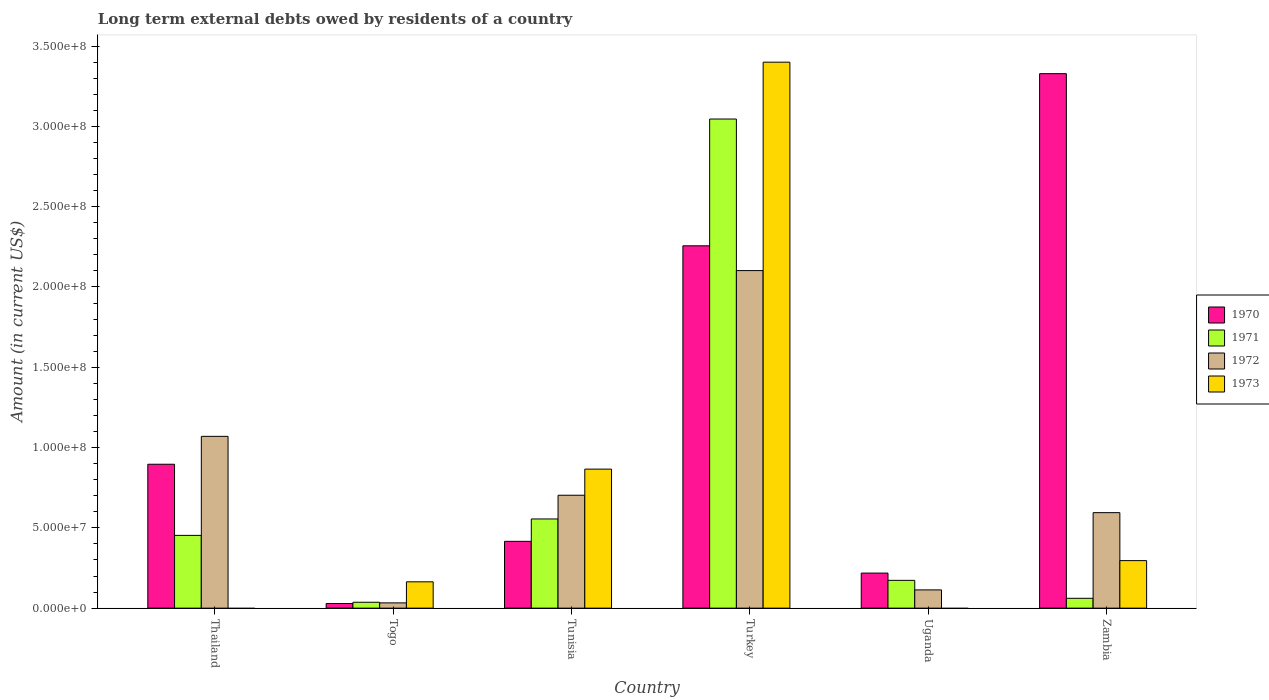How many different coloured bars are there?
Give a very brief answer. 4. How many groups of bars are there?
Offer a very short reply. 6. How many bars are there on the 5th tick from the left?
Give a very brief answer. 3. How many bars are there on the 4th tick from the right?
Your response must be concise. 4. What is the label of the 3rd group of bars from the left?
Provide a short and direct response. Tunisia. In how many cases, is the number of bars for a given country not equal to the number of legend labels?
Give a very brief answer. 2. What is the amount of long-term external debts owed by residents in 1972 in Zambia?
Your response must be concise. 5.95e+07. Across all countries, what is the maximum amount of long-term external debts owed by residents in 1970?
Your response must be concise. 3.33e+08. Across all countries, what is the minimum amount of long-term external debts owed by residents in 1972?
Keep it short and to the point. 3.28e+06. In which country was the amount of long-term external debts owed by residents in 1971 maximum?
Keep it short and to the point. Turkey. What is the total amount of long-term external debts owed by residents in 1973 in the graph?
Offer a very short reply. 4.73e+08. What is the difference between the amount of long-term external debts owed by residents in 1972 in Togo and that in Turkey?
Provide a succinct answer. -2.07e+08. What is the difference between the amount of long-term external debts owed by residents in 1972 in Tunisia and the amount of long-term external debts owed by residents in 1970 in Zambia?
Ensure brevity in your answer.  -2.62e+08. What is the average amount of long-term external debts owed by residents in 1973 per country?
Make the answer very short. 7.88e+07. What is the difference between the amount of long-term external debts owed by residents of/in 1970 and amount of long-term external debts owed by residents of/in 1973 in Zambia?
Your answer should be very brief. 3.03e+08. What is the ratio of the amount of long-term external debts owed by residents in 1972 in Togo to that in Tunisia?
Offer a very short reply. 0.05. Is the difference between the amount of long-term external debts owed by residents in 1970 in Tunisia and Zambia greater than the difference between the amount of long-term external debts owed by residents in 1973 in Tunisia and Zambia?
Make the answer very short. No. What is the difference between the highest and the second highest amount of long-term external debts owed by residents in 1970?
Ensure brevity in your answer.  2.43e+08. What is the difference between the highest and the lowest amount of long-term external debts owed by residents in 1970?
Offer a terse response. 3.30e+08. Is it the case that in every country, the sum of the amount of long-term external debts owed by residents in 1971 and amount of long-term external debts owed by residents in 1970 is greater than the sum of amount of long-term external debts owed by residents in 1973 and amount of long-term external debts owed by residents in 1972?
Your answer should be very brief. No. How many bars are there?
Your answer should be very brief. 22. What is the difference between two consecutive major ticks on the Y-axis?
Provide a short and direct response. 5.00e+07. Where does the legend appear in the graph?
Provide a succinct answer. Center right. How many legend labels are there?
Ensure brevity in your answer.  4. How are the legend labels stacked?
Offer a terse response. Vertical. What is the title of the graph?
Offer a terse response. Long term external debts owed by residents of a country. What is the Amount (in current US$) of 1970 in Thailand?
Your answer should be compact. 8.96e+07. What is the Amount (in current US$) in 1971 in Thailand?
Make the answer very short. 4.53e+07. What is the Amount (in current US$) of 1972 in Thailand?
Offer a terse response. 1.07e+08. What is the Amount (in current US$) of 1973 in Thailand?
Your answer should be very brief. 0. What is the Amount (in current US$) of 1970 in Togo?
Your response must be concise. 2.89e+06. What is the Amount (in current US$) in 1971 in Togo?
Make the answer very short. 3.67e+06. What is the Amount (in current US$) of 1972 in Togo?
Your response must be concise. 3.28e+06. What is the Amount (in current US$) in 1973 in Togo?
Your response must be concise. 1.64e+07. What is the Amount (in current US$) of 1970 in Tunisia?
Your answer should be very brief. 4.16e+07. What is the Amount (in current US$) in 1971 in Tunisia?
Offer a terse response. 5.55e+07. What is the Amount (in current US$) of 1972 in Tunisia?
Your answer should be very brief. 7.03e+07. What is the Amount (in current US$) of 1973 in Tunisia?
Provide a short and direct response. 8.66e+07. What is the Amount (in current US$) in 1970 in Turkey?
Your answer should be very brief. 2.26e+08. What is the Amount (in current US$) of 1971 in Turkey?
Make the answer very short. 3.05e+08. What is the Amount (in current US$) in 1972 in Turkey?
Ensure brevity in your answer.  2.10e+08. What is the Amount (in current US$) in 1973 in Turkey?
Your response must be concise. 3.40e+08. What is the Amount (in current US$) of 1970 in Uganda?
Keep it short and to the point. 2.18e+07. What is the Amount (in current US$) in 1971 in Uganda?
Offer a very short reply. 1.73e+07. What is the Amount (in current US$) in 1972 in Uganda?
Provide a succinct answer. 1.14e+07. What is the Amount (in current US$) of 1970 in Zambia?
Your response must be concise. 3.33e+08. What is the Amount (in current US$) in 1971 in Zambia?
Give a very brief answer. 6.13e+06. What is the Amount (in current US$) in 1972 in Zambia?
Make the answer very short. 5.95e+07. What is the Amount (in current US$) of 1973 in Zambia?
Give a very brief answer. 2.96e+07. Across all countries, what is the maximum Amount (in current US$) in 1970?
Ensure brevity in your answer.  3.33e+08. Across all countries, what is the maximum Amount (in current US$) in 1971?
Ensure brevity in your answer.  3.05e+08. Across all countries, what is the maximum Amount (in current US$) in 1972?
Keep it short and to the point. 2.10e+08. Across all countries, what is the maximum Amount (in current US$) in 1973?
Offer a terse response. 3.40e+08. Across all countries, what is the minimum Amount (in current US$) of 1970?
Provide a succinct answer. 2.89e+06. Across all countries, what is the minimum Amount (in current US$) in 1971?
Make the answer very short. 3.67e+06. Across all countries, what is the minimum Amount (in current US$) of 1972?
Your answer should be compact. 3.28e+06. Across all countries, what is the minimum Amount (in current US$) in 1973?
Keep it short and to the point. 0. What is the total Amount (in current US$) of 1970 in the graph?
Make the answer very short. 7.14e+08. What is the total Amount (in current US$) of 1971 in the graph?
Offer a very short reply. 4.33e+08. What is the total Amount (in current US$) in 1972 in the graph?
Make the answer very short. 4.62e+08. What is the total Amount (in current US$) of 1973 in the graph?
Keep it short and to the point. 4.73e+08. What is the difference between the Amount (in current US$) of 1970 in Thailand and that in Togo?
Offer a terse response. 8.67e+07. What is the difference between the Amount (in current US$) of 1971 in Thailand and that in Togo?
Offer a very short reply. 4.16e+07. What is the difference between the Amount (in current US$) in 1972 in Thailand and that in Togo?
Make the answer very short. 1.04e+08. What is the difference between the Amount (in current US$) in 1970 in Thailand and that in Tunisia?
Keep it short and to the point. 4.80e+07. What is the difference between the Amount (in current US$) of 1971 in Thailand and that in Tunisia?
Keep it short and to the point. -1.02e+07. What is the difference between the Amount (in current US$) of 1972 in Thailand and that in Tunisia?
Your answer should be very brief. 3.67e+07. What is the difference between the Amount (in current US$) in 1970 in Thailand and that in Turkey?
Your answer should be very brief. -1.36e+08. What is the difference between the Amount (in current US$) in 1971 in Thailand and that in Turkey?
Provide a succinct answer. -2.59e+08. What is the difference between the Amount (in current US$) of 1972 in Thailand and that in Turkey?
Provide a short and direct response. -1.03e+08. What is the difference between the Amount (in current US$) of 1970 in Thailand and that in Uganda?
Offer a terse response. 6.78e+07. What is the difference between the Amount (in current US$) of 1971 in Thailand and that in Uganda?
Your response must be concise. 2.80e+07. What is the difference between the Amount (in current US$) in 1972 in Thailand and that in Uganda?
Offer a very short reply. 9.56e+07. What is the difference between the Amount (in current US$) in 1970 in Thailand and that in Zambia?
Your response must be concise. -2.43e+08. What is the difference between the Amount (in current US$) in 1971 in Thailand and that in Zambia?
Make the answer very short. 3.92e+07. What is the difference between the Amount (in current US$) of 1972 in Thailand and that in Zambia?
Provide a short and direct response. 4.75e+07. What is the difference between the Amount (in current US$) of 1970 in Togo and that in Tunisia?
Make the answer very short. -3.87e+07. What is the difference between the Amount (in current US$) of 1971 in Togo and that in Tunisia?
Provide a short and direct response. -5.19e+07. What is the difference between the Amount (in current US$) in 1972 in Togo and that in Tunisia?
Keep it short and to the point. -6.70e+07. What is the difference between the Amount (in current US$) in 1973 in Togo and that in Tunisia?
Make the answer very short. -7.02e+07. What is the difference between the Amount (in current US$) in 1970 in Togo and that in Turkey?
Your answer should be compact. -2.23e+08. What is the difference between the Amount (in current US$) of 1971 in Togo and that in Turkey?
Make the answer very short. -3.01e+08. What is the difference between the Amount (in current US$) of 1972 in Togo and that in Turkey?
Make the answer very short. -2.07e+08. What is the difference between the Amount (in current US$) of 1973 in Togo and that in Turkey?
Make the answer very short. -3.24e+08. What is the difference between the Amount (in current US$) of 1970 in Togo and that in Uganda?
Offer a very short reply. -1.89e+07. What is the difference between the Amount (in current US$) of 1971 in Togo and that in Uganda?
Offer a terse response. -1.36e+07. What is the difference between the Amount (in current US$) of 1972 in Togo and that in Uganda?
Provide a succinct answer. -8.09e+06. What is the difference between the Amount (in current US$) of 1970 in Togo and that in Zambia?
Make the answer very short. -3.30e+08. What is the difference between the Amount (in current US$) of 1971 in Togo and that in Zambia?
Offer a terse response. -2.46e+06. What is the difference between the Amount (in current US$) of 1972 in Togo and that in Zambia?
Provide a short and direct response. -5.62e+07. What is the difference between the Amount (in current US$) in 1973 in Togo and that in Zambia?
Your answer should be compact. -1.32e+07. What is the difference between the Amount (in current US$) in 1970 in Tunisia and that in Turkey?
Provide a short and direct response. -1.84e+08. What is the difference between the Amount (in current US$) in 1971 in Tunisia and that in Turkey?
Ensure brevity in your answer.  -2.49e+08. What is the difference between the Amount (in current US$) of 1972 in Tunisia and that in Turkey?
Ensure brevity in your answer.  -1.40e+08. What is the difference between the Amount (in current US$) in 1973 in Tunisia and that in Turkey?
Provide a succinct answer. -2.53e+08. What is the difference between the Amount (in current US$) of 1970 in Tunisia and that in Uganda?
Give a very brief answer. 1.98e+07. What is the difference between the Amount (in current US$) of 1971 in Tunisia and that in Uganda?
Ensure brevity in your answer.  3.82e+07. What is the difference between the Amount (in current US$) in 1972 in Tunisia and that in Uganda?
Your response must be concise. 5.89e+07. What is the difference between the Amount (in current US$) of 1970 in Tunisia and that in Zambia?
Your response must be concise. -2.91e+08. What is the difference between the Amount (in current US$) in 1971 in Tunisia and that in Zambia?
Offer a terse response. 4.94e+07. What is the difference between the Amount (in current US$) of 1972 in Tunisia and that in Zambia?
Ensure brevity in your answer.  1.08e+07. What is the difference between the Amount (in current US$) in 1973 in Tunisia and that in Zambia?
Make the answer very short. 5.70e+07. What is the difference between the Amount (in current US$) of 1970 in Turkey and that in Uganda?
Ensure brevity in your answer.  2.04e+08. What is the difference between the Amount (in current US$) of 1971 in Turkey and that in Uganda?
Keep it short and to the point. 2.87e+08. What is the difference between the Amount (in current US$) in 1972 in Turkey and that in Uganda?
Give a very brief answer. 1.99e+08. What is the difference between the Amount (in current US$) in 1970 in Turkey and that in Zambia?
Ensure brevity in your answer.  -1.07e+08. What is the difference between the Amount (in current US$) in 1971 in Turkey and that in Zambia?
Offer a terse response. 2.98e+08. What is the difference between the Amount (in current US$) of 1972 in Turkey and that in Zambia?
Give a very brief answer. 1.51e+08. What is the difference between the Amount (in current US$) of 1973 in Turkey and that in Zambia?
Offer a terse response. 3.10e+08. What is the difference between the Amount (in current US$) in 1970 in Uganda and that in Zambia?
Provide a succinct answer. -3.11e+08. What is the difference between the Amount (in current US$) of 1971 in Uganda and that in Zambia?
Offer a very short reply. 1.12e+07. What is the difference between the Amount (in current US$) in 1972 in Uganda and that in Zambia?
Offer a terse response. -4.81e+07. What is the difference between the Amount (in current US$) in 1970 in Thailand and the Amount (in current US$) in 1971 in Togo?
Offer a very short reply. 8.59e+07. What is the difference between the Amount (in current US$) of 1970 in Thailand and the Amount (in current US$) of 1972 in Togo?
Make the answer very short. 8.63e+07. What is the difference between the Amount (in current US$) in 1970 in Thailand and the Amount (in current US$) in 1973 in Togo?
Make the answer very short. 7.32e+07. What is the difference between the Amount (in current US$) of 1971 in Thailand and the Amount (in current US$) of 1972 in Togo?
Give a very brief answer. 4.20e+07. What is the difference between the Amount (in current US$) in 1971 in Thailand and the Amount (in current US$) in 1973 in Togo?
Your response must be concise. 2.89e+07. What is the difference between the Amount (in current US$) in 1972 in Thailand and the Amount (in current US$) in 1973 in Togo?
Ensure brevity in your answer.  9.06e+07. What is the difference between the Amount (in current US$) of 1970 in Thailand and the Amount (in current US$) of 1971 in Tunisia?
Provide a succinct answer. 3.41e+07. What is the difference between the Amount (in current US$) of 1970 in Thailand and the Amount (in current US$) of 1972 in Tunisia?
Ensure brevity in your answer.  1.93e+07. What is the difference between the Amount (in current US$) of 1970 in Thailand and the Amount (in current US$) of 1973 in Tunisia?
Give a very brief answer. 3.04e+06. What is the difference between the Amount (in current US$) of 1971 in Thailand and the Amount (in current US$) of 1972 in Tunisia?
Offer a terse response. -2.50e+07. What is the difference between the Amount (in current US$) in 1971 in Thailand and the Amount (in current US$) in 1973 in Tunisia?
Offer a terse response. -4.13e+07. What is the difference between the Amount (in current US$) of 1972 in Thailand and the Amount (in current US$) of 1973 in Tunisia?
Offer a very short reply. 2.04e+07. What is the difference between the Amount (in current US$) in 1970 in Thailand and the Amount (in current US$) in 1971 in Turkey?
Offer a very short reply. -2.15e+08. What is the difference between the Amount (in current US$) in 1970 in Thailand and the Amount (in current US$) in 1972 in Turkey?
Your answer should be very brief. -1.21e+08. What is the difference between the Amount (in current US$) in 1970 in Thailand and the Amount (in current US$) in 1973 in Turkey?
Your response must be concise. -2.50e+08. What is the difference between the Amount (in current US$) of 1971 in Thailand and the Amount (in current US$) of 1972 in Turkey?
Offer a terse response. -1.65e+08. What is the difference between the Amount (in current US$) of 1971 in Thailand and the Amount (in current US$) of 1973 in Turkey?
Make the answer very short. -2.95e+08. What is the difference between the Amount (in current US$) of 1972 in Thailand and the Amount (in current US$) of 1973 in Turkey?
Make the answer very short. -2.33e+08. What is the difference between the Amount (in current US$) of 1970 in Thailand and the Amount (in current US$) of 1971 in Uganda?
Your answer should be compact. 7.23e+07. What is the difference between the Amount (in current US$) of 1970 in Thailand and the Amount (in current US$) of 1972 in Uganda?
Your answer should be compact. 7.82e+07. What is the difference between the Amount (in current US$) in 1971 in Thailand and the Amount (in current US$) in 1972 in Uganda?
Keep it short and to the point. 3.39e+07. What is the difference between the Amount (in current US$) in 1970 in Thailand and the Amount (in current US$) in 1971 in Zambia?
Your answer should be very brief. 8.35e+07. What is the difference between the Amount (in current US$) in 1970 in Thailand and the Amount (in current US$) in 1972 in Zambia?
Ensure brevity in your answer.  3.01e+07. What is the difference between the Amount (in current US$) of 1970 in Thailand and the Amount (in current US$) of 1973 in Zambia?
Your response must be concise. 6.00e+07. What is the difference between the Amount (in current US$) of 1971 in Thailand and the Amount (in current US$) of 1972 in Zambia?
Make the answer very short. -1.42e+07. What is the difference between the Amount (in current US$) of 1971 in Thailand and the Amount (in current US$) of 1973 in Zambia?
Provide a short and direct response. 1.57e+07. What is the difference between the Amount (in current US$) of 1972 in Thailand and the Amount (in current US$) of 1973 in Zambia?
Ensure brevity in your answer.  7.74e+07. What is the difference between the Amount (in current US$) in 1970 in Togo and the Amount (in current US$) in 1971 in Tunisia?
Offer a very short reply. -5.26e+07. What is the difference between the Amount (in current US$) of 1970 in Togo and the Amount (in current US$) of 1972 in Tunisia?
Give a very brief answer. -6.74e+07. What is the difference between the Amount (in current US$) of 1970 in Togo and the Amount (in current US$) of 1973 in Tunisia?
Your response must be concise. -8.37e+07. What is the difference between the Amount (in current US$) of 1971 in Togo and the Amount (in current US$) of 1972 in Tunisia?
Your answer should be compact. -6.66e+07. What is the difference between the Amount (in current US$) of 1971 in Togo and the Amount (in current US$) of 1973 in Tunisia?
Your answer should be compact. -8.29e+07. What is the difference between the Amount (in current US$) of 1972 in Togo and the Amount (in current US$) of 1973 in Tunisia?
Offer a terse response. -8.33e+07. What is the difference between the Amount (in current US$) of 1970 in Togo and the Amount (in current US$) of 1971 in Turkey?
Provide a short and direct response. -3.02e+08. What is the difference between the Amount (in current US$) of 1970 in Togo and the Amount (in current US$) of 1972 in Turkey?
Ensure brevity in your answer.  -2.07e+08. What is the difference between the Amount (in current US$) in 1970 in Togo and the Amount (in current US$) in 1973 in Turkey?
Keep it short and to the point. -3.37e+08. What is the difference between the Amount (in current US$) of 1971 in Togo and the Amount (in current US$) of 1972 in Turkey?
Offer a terse response. -2.07e+08. What is the difference between the Amount (in current US$) in 1971 in Togo and the Amount (in current US$) in 1973 in Turkey?
Your answer should be very brief. -3.36e+08. What is the difference between the Amount (in current US$) of 1972 in Togo and the Amount (in current US$) of 1973 in Turkey?
Your answer should be very brief. -3.37e+08. What is the difference between the Amount (in current US$) in 1970 in Togo and the Amount (in current US$) in 1971 in Uganda?
Give a very brief answer. -1.44e+07. What is the difference between the Amount (in current US$) in 1970 in Togo and the Amount (in current US$) in 1972 in Uganda?
Your answer should be very brief. -8.47e+06. What is the difference between the Amount (in current US$) in 1971 in Togo and the Amount (in current US$) in 1972 in Uganda?
Make the answer very short. -7.70e+06. What is the difference between the Amount (in current US$) of 1970 in Togo and the Amount (in current US$) of 1971 in Zambia?
Offer a very short reply. -3.24e+06. What is the difference between the Amount (in current US$) of 1970 in Togo and the Amount (in current US$) of 1972 in Zambia?
Make the answer very short. -5.66e+07. What is the difference between the Amount (in current US$) in 1970 in Togo and the Amount (in current US$) in 1973 in Zambia?
Offer a very short reply. -2.67e+07. What is the difference between the Amount (in current US$) in 1971 in Togo and the Amount (in current US$) in 1972 in Zambia?
Keep it short and to the point. -5.58e+07. What is the difference between the Amount (in current US$) in 1971 in Togo and the Amount (in current US$) in 1973 in Zambia?
Keep it short and to the point. -2.59e+07. What is the difference between the Amount (in current US$) of 1972 in Togo and the Amount (in current US$) of 1973 in Zambia?
Provide a succinct answer. -2.63e+07. What is the difference between the Amount (in current US$) in 1970 in Tunisia and the Amount (in current US$) in 1971 in Turkey?
Provide a succinct answer. -2.63e+08. What is the difference between the Amount (in current US$) in 1970 in Tunisia and the Amount (in current US$) in 1972 in Turkey?
Make the answer very short. -1.69e+08. What is the difference between the Amount (in current US$) of 1970 in Tunisia and the Amount (in current US$) of 1973 in Turkey?
Offer a very short reply. -2.98e+08. What is the difference between the Amount (in current US$) of 1971 in Tunisia and the Amount (in current US$) of 1972 in Turkey?
Give a very brief answer. -1.55e+08. What is the difference between the Amount (in current US$) in 1971 in Tunisia and the Amount (in current US$) in 1973 in Turkey?
Offer a terse response. -2.84e+08. What is the difference between the Amount (in current US$) of 1972 in Tunisia and the Amount (in current US$) of 1973 in Turkey?
Offer a terse response. -2.70e+08. What is the difference between the Amount (in current US$) in 1970 in Tunisia and the Amount (in current US$) in 1971 in Uganda?
Offer a very short reply. 2.43e+07. What is the difference between the Amount (in current US$) of 1970 in Tunisia and the Amount (in current US$) of 1972 in Uganda?
Your response must be concise. 3.02e+07. What is the difference between the Amount (in current US$) of 1971 in Tunisia and the Amount (in current US$) of 1972 in Uganda?
Keep it short and to the point. 4.42e+07. What is the difference between the Amount (in current US$) of 1970 in Tunisia and the Amount (in current US$) of 1971 in Zambia?
Provide a short and direct response. 3.55e+07. What is the difference between the Amount (in current US$) in 1970 in Tunisia and the Amount (in current US$) in 1972 in Zambia?
Provide a succinct answer. -1.79e+07. What is the difference between the Amount (in current US$) in 1970 in Tunisia and the Amount (in current US$) in 1973 in Zambia?
Ensure brevity in your answer.  1.20e+07. What is the difference between the Amount (in current US$) of 1971 in Tunisia and the Amount (in current US$) of 1972 in Zambia?
Provide a succinct answer. -3.93e+06. What is the difference between the Amount (in current US$) in 1971 in Tunisia and the Amount (in current US$) in 1973 in Zambia?
Your response must be concise. 2.59e+07. What is the difference between the Amount (in current US$) of 1972 in Tunisia and the Amount (in current US$) of 1973 in Zambia?
Offer a terse response. 4.07e+07. What is the difference between the Amount (in current US$) of 1970 in Turkey and the Amount (in current US$) of 1971 in Uganda?
Offer a very short reply. 2.08e+08. What is the difference between the Amount (in current US$) of 1970 in Turkey and the Amount (in current US$) of 1972 in Uganda?
Your answer should be very brief. 2.14e+08. What is the difference between the Amount (in current US$) in 1971 in Turkey and the Amount (in current US$) in 1972 in Uganda?
Make the answer very short. 2.93e+08. What is the difference between the Amount (in current US$) of 1970 in Turkey and the Amount (in current US$) of 1971 in Zambia?
Your response must be concise. 2.19e+08. What is the difference between the Amount (in current US$) of 1970 in Turkey and the Amount (in current US$) of 1972 in Zambia?
Give a very brief answer. 1.66e+08. What is the difference between the Amount (in current US$) of 1970 in Turkey and the Amount (in current US$) of 1973 in Zambia?
Your response must be concise. 1.96e+08. What is the difference between the Amount (in current US$) of 1971 in Turkey and the Amount (in current US$) of 1972 in Zambia?
Offer a very short reply. 2.45e+08. What is the difference between the Amount (in current US$) of 1971 in Turkey and the Amount (in current US$) of 1973 in Zambia?
Make the answer very short. 2.75e+08. What is the difference between the Amount (in current US$) in 1972 in Turkey and the Amount (in current US$) in 1973 in Zambia?
Give a very brief answer. 1.81e+08. What is the difference between the Amount (in current US$) of 1970 in Uganda and the Amount (in current US$) of 1971 in Zambia?
Your response must be concise. 1.57e+07. What is the difference between the Amount (in current US$) in 1970 in Uganda and the Amount (in current US$) in 1972 in Zambia?
Your answer should be compact. -3.76e+07. What is the difference between the Amount (in current US$) of 1970 in Uganda and the Amount (in current US$) of 1973 in Zambia?
Your response must be concise. -7.76e+06. What is the difference between the Amount (in current US$) in 1971 in Uganda and the Amount (in current US$) in 1972 in Zambia?
Provide a succinct answer. -4.22e+07. What is the difference between the Amount (in current US$) in 1971 in Uganda and the Amount (in current US$) in 1973 in Zambia?
Make the answer very short. -1.23e+07. What is the difference between the Amount (in current US$) in 1972 in Uganda and the Amount (in current US$) in 1973 in Zambia?
Offer a very short reply. -1.82e+07. What is the average Amount (in current US$) in 1970 per country?
Provide a short and direct response. 1.19e+08. What is the average Amount (in current US$) of 1971 per country?
Ensure brevity in your answer.  7.21e+07. What is the average Amount (in current US$) of 1972 per country?
Offer a terse response. 7.69e+07. What is the average Amount (in current US$) of 1973 per country?
Give a very brief answer. 7.88e+07. What is the difference between the Amount (in current US$) of 1970 and Amount (in current US$) of 1971 in Thailand?
Your response must be concise. 4.43e+07. What is the difference between the Amount (in current US$) in 1970 and Amount (in current US$) in 1972 in Thailand?
Your answer should be compact. -1.74e+07. What is the difference between the Amount (in current US$) of 1971 and Amount (in current US$) of 1972 in Thailand?
Provide a short and direct response. -6.17e+07. What is the difference between the Amount (in current US$) in 1970 and Amount (in current US$) in 1971 in Togo?
Provide a short and direct response. -7.77e+05. What is the difference between the Amount (in current US$) in 1970 and Amount (in current US$) in 1972 in Togo?
Your answer should be very brief. -3.88e+05. What is the difference between the Amount (in current US$) in 1970 and Amount (in current US$) in 1973 in Togo?
Your answer should be very brief. -1.35e+07. What is the difference between the Amount (in current US$) in 1971 and Amount (in current US$) in 1972 in Togo?
Your answer should be compact. 3.89e+05. What is the difference between the Amount (in current US$) of 1971 and Amount (in current US$) of 1973 in Togo?
Provide a short and direct response. -1.27e+07. What is the difference between the Amount (in current US$) of 1972 and Amount (in current US$) of 1973 in Togo?
Offer a very short reply. -1.31e+07. What is the difference between the Amount (in current US$) in 1970 and Amount (in current US$) in 1971 in Tunisia?
Your answer should be very brief. -1.39e+07. What is the difference between the Amount (in current US$) of 1970 and Amount (in current US$) of 1972 in Tunisia?
Offer a very short reply. -2.87e+07. What is the difference between the Amount (in current US$) in 1970 and Amount (in current US$) in 1973 in Tunisia?
Provide a succinct answer. -4.50e+07. What is the difference between the Amount (in current US$) of 1971 and Amount (in current US$) of 1972 in Tunisia?
Make the answer very short. -1.48e+07. What is the difference between the Amount (in current US$) in 1971 and Amount (in current US$) in 1973 in Tunisia?
Offer a very short reply. -3.10e+07. What is the difference between the Amount (in current US$) in 1972 and Amount (in current US$) in 1973 in Tunisia?
Keep it short and to the point. -1.63e+07. What is the difference between the Amount (in current US$) in 1970 and Amount (in current US$) in 1971 in Turkey?
Your answer should be compact. -7.89e+07. What is the difference between the Amount (in current US$) in 1970 and Amount (in current US$) in 1972 in Turkey?
Your answer should be very brief. 1.54e+07. What is the difference between the Amount (in current US$) in 1970 and Amount (in current US$) in 1973 in Turkey?
Offer a terse response. -1.14e+08. What is the difference between the Amount (in current US$) in 1971 and Amount (in current US$) in 1972 in Turkey?
Your response must be concise. 9.44e+07. What is the difference between the Amount (in current US$) of 1971 and Amount (in current US$) of 1973 in Turkey?
Offer a terse response. -3.54e+07. What is the difference between the Amount (in current US$) of 1972 and Amount (in current US$) of 1973 in Turkey?
Give a very brief answer. -1.30e+08. What is the difference between the Amount (in current US$) of 1970 and Amount (in current US$) of 1971 in Uganda?
Your response must be concise. 4.52e+06. What is the difference between the Amount (in current US$) of 1970 and Amount (in current US$) of 1972 in Uganda?
Your answer should be very brief. 1.05e+07. What is the difference between the Amount (in current US$) in 1971 and Amount (in current US$) in 1972 in Uganda?
Make the answer very short. 5.94e+06. What is the difference between the Amount (in current US$) in 1970 and Amount (in current US$) in 1971 in Zambia?
Offer a terse response. 3.27e+08. What is the difference between the Amount (in current US$) in 1970 and Amount (in current US$) in 1972 in Zambia?
Offer a terse response. 2.73e+08. What is the difference between the Amount (in current US$) in 1970 and Amount (in current US$) in 1973 in Zambia?
Provide a succinct answer. 3.03e+08. What is the difference between the Amount (in current US$) in 1971 and Amount (in current US$) in 1972 in Zambia?
Your answer should be very brief. -5.33e+07. What is the difference between the Amount (in current US$) in 1971 and Amount (in current US$) in 1973 in Zambia?
Provide a succinct answer. -2.35e+07. What is the difference between the Amount (in current US$) of 1972 and Amount (in current US$) of 1973 in Zambia?
Provide a succinct answer. 2.99e+07. What is the ratio of the Amount (in current US$) in 1970 in Thailand to that in Togo?
Give a very brief answer. 30.99. What is the ratio of the Amount (in current US$) in 1971 in Thailand to that in Togo?
Provide a succinct answer. 12.35. What is the ratio of the Amount (in current US$) of 1972 in Thailand to that in Togo?
Provide a short and direct response. 32.62. What is the ratio of the Amount (in current US$) of 1970 in Thailand to that in Tunisia?
Provide a short and direct response. 2.15. What is the ratio of the Amount (in current US$) in 1971 in Thailand to that in Tunisia?
Make the answer very short. 0.82. What is the ratio of the Amount (in current US$) in 1972 in Thailand to that in Tunisia?
Provide a short and direct response. 1.52. What is the ratio of the Amount (in current US$) of 1970 in Thailand to that in Turkey?
Your answer should be very brief. 0.4. What is the ratio of the Amount (in current US$) of 1971 in Thailand to that in Turkey?
Your answer should be very brief. 0.15. What is the ratio of the Amount (in current US$) in 1972 in Thailand to that in Turkey?
Your answer should be compact. 0.51. What is the ratio of the Amount (in current US$) of 1970 in Thailand to that in Uganda?
Give a very brief answer. 4.11. What is the ratio of the Amount (in current US$) in 1971 in Thailand to that in Uganda?
Your answer should be very brief. 2.62. What is the ratio of the Amount (in current US$) in 1972 in Thailand to that in Uganda?
Give a very brief answer. 9.41. What is the ratio of the Amount (in current US$) in 1970 in Thailand to that in Zambia?
Your answer should be compact. 0.27. What is the ratio of the Amount (in current US$) in 1971 in Thailand to that in Zambia?
Your answer should be compact. 7.39. What is the ratio of the Amount (in current US$) in 1972 in Thailand to that in Zambia?
Provide a short and direct response. 1.8. What is the ratio of the Amount (in current US$) of 1970 in Togo to that in Tunisia?
Provide a short and direct response. 0.07. What is the ratio of the Amount (in current US$) in 1971 in Togo to that in Tunisia?
Your answer should be very brief. 0.07. What is the ratio of the Amount (in current US$) in 1972 in Togo to that in Tunisia?
Your answer should be very brief. 0.05. What is the ratio of the Amount (in current US$) in 1973 in Togo to that in Tunisia?
Provide a short and direct response. 0.19. What is the ratio of the Amount (in current US$) in 1970 in Togo to that in Turkey?
Keep it short and to the point. 0.01. What is the ratio of the Amount (in current US$) in 1971 in Togo to that in Turkey?
Keep it short and to the point. 0.01. What is the ratio of the Amount (in current US$) of 1972 in Togo to that in Turkey?
Your answer should be compact. 0.02. What is the ratio of the Amount (in current US$) of 1973 in Togo to that in Turkey?
Keep it short and to the point. 0.05. What is the ratio of the Amount (in current US$) in 1970 in Togo to that in Uganda?
Offer a terse response. 0.13. What is the ratio of the Amount (in current US$) of 1971 in Togo to that in Uganda?
Ensure brevity in your answer.  0.21. What is the ratio of the Amount (in current US$) in 1972 in Togo to that in Uganda?
Your answer should be very brief. 0.29. What is the ratio of the Amount (in current US$) of 1970 in Togo to that in Zambia?
Your answer should be compact. 0.01. What is the ratio of the Amount (in current US$) of 1971 in Togo to that in Zambia?
Provide a short and direct response. 0.6. What is the ratio of the Amount (in current US$) in 1972 in Togo to that in Zambia?
Ensure brevity in your answer.  0.06. What is the ratio of the Amount (in current US$) of 1973 in Togo to that in Zambia?
Your answer should be very brief. 0.55. What is the ratio of the Amount (in current US$) in 1970 in Tunisia to that in Turkey?
Offer a very short reply. 0.18. What is the ratio of the Amount (in current US$) of 1971 in Tunisia to that in Turkey?
Your response must be concise. 0.18. What is the ratio of the Amount (in current US$) in 1972 in Tunisia to that in Turkey?
Make the answer very short. 0.33. What is the ratio of the Amount (in current US$) in 1973 in Tunisia to that in Turkey?
Offer a terse response. 0.25. What is the ratio of the Amount (in current US$) of 1970 in Tunisia to that in Uganda?
Give a very brief answer. 1.91. What is the ratio of the Amount (in current US$) of 1971 in Tunisia to that in Uganda?
Offer a very short reply. 3.21. What is the ratio of the Amount (in current US$) of 1972 in Tunisia to that in Uganda?
Your answer should be compact. 6.19. What is the ratio of the Amount (in current US$) of 1970 in Tunisia to that in Zambia?
Make the answer very short. 0.12. What is the ratio of the Amount (in current US$) in 1971 in Tunisia to that in Zambia?
Offer a very short reply. 9.06. What is the ratio of the Amount (in current US$) in 1972 in Tunisia to that in Zambia?
Ensure brevity in your answer.  1.18. What is the ratio of the Amount (in current US$) in 1973 in Tunisia to that in Zambia?
Your answer should be compact. 2.93. What is the ratio of the Amount (in current US$) of 1970 in Turkey to that in Uganda?
Ensure brevity in your answer.  10.34. What is the ratio of the Amount (in current US$) in 1971 in Turkey to that in Uganda?
Your answer should be very brief. 17.6. What is the ratio of the Amount (in current US$) in 1972 in Turkey to that in Uganda?
Your response must be concise. 18.49. What is the ratio of the Amount (in current US$) of 1970 in Turkey to that in Zambia?
Make the answer very short. 0.68. What is the ratio of the Amount (in current US$) of 1971 in Turkey to that in Zambia?
Provide a short and direct response. 49.68. What is the ratio of the Amount (in current US$) in 1972 in Turkey to that in Zambia?
Give a very brief answer. 3.53. What is the ratio of the Amount (in current US$) of 1973 in Turkey to that in Zambia?
Ensure brevity in your answer.  11.49. What is the ratio of the Amount (in current US$) in 1970 in Uganda to that in Zambia?
Your answer should be very brief. 0.07. What is the ratio of the Amount (in current US$) in 1971 in Uganda to that in Zambia?
Keep it short and to the point. 2.82. What is the ratio of the Amount (in current US$) in 1972 in Uganda to that in Zambia?
Provide a short and direct response. 0.19. What is the difference between the highest and the second highest Amount (in current US$) of 1970?
Your response must be concise. 1.07e+08. What is the difference between the highest and the second highest Amount (in current US$) of 1971?
Your response must be concise. 2.49e+08. What is the difference between the highest and the second highest Amount (in current US$) in 1972?
Your response must be concise. 1.03e+08. What is the difference between the highest and the second highest Amount (in current US$) in 1973?
Keep it short and to the point. 2.53e+08. What is the difference between the highest and the lowest Amount (in current US$) of 1970?
Offer a very short reply. 3.30e+08. What is the difference between the highest and the lowest Amount (in current US$) of 1971?
Provide a short and direct response. 3.01e+08. What is the difference between the highest and the lowest Amount (in current US$) in 1972?
Offer a terse response. 2.07e+08. What is the difference between the highest and the lowest Amount (in current US$) of 1973?
Your answer should be very brief. 3.40e+08. 